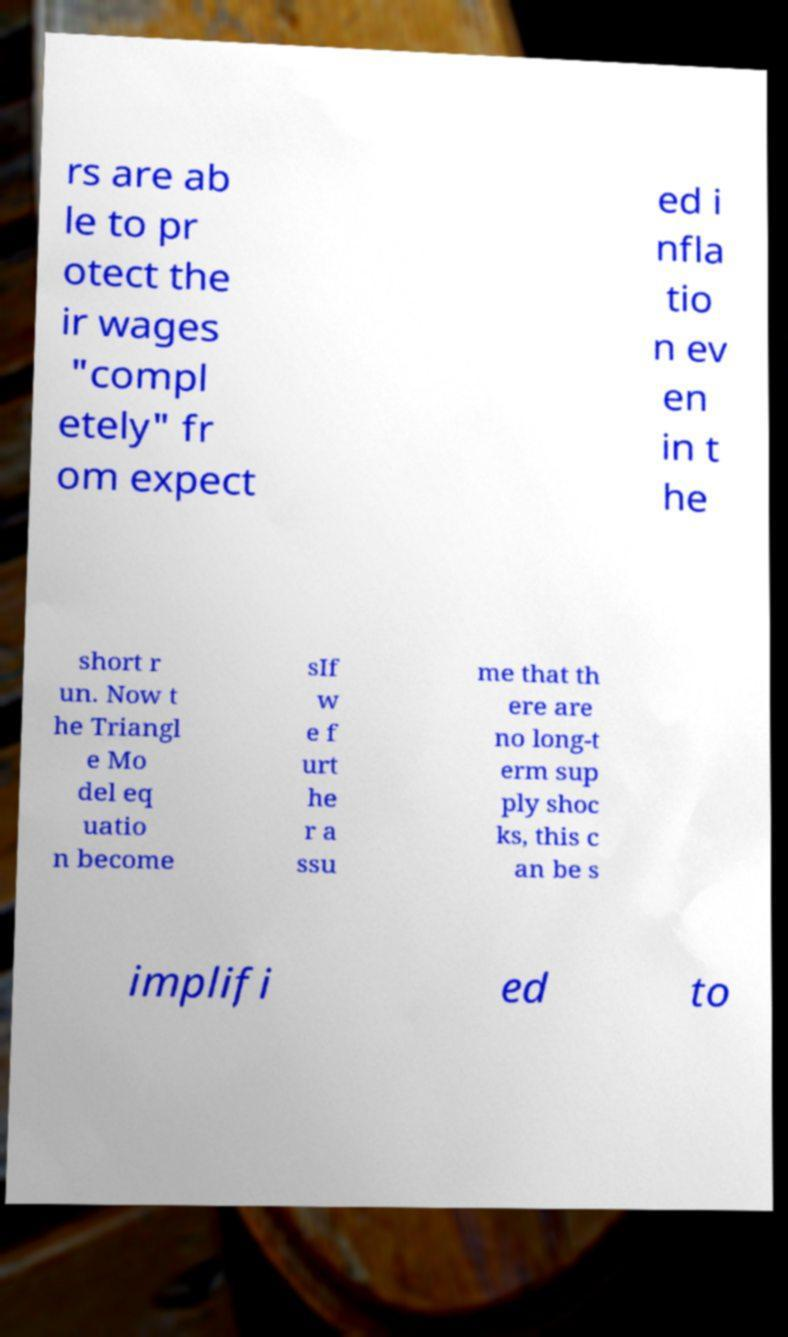Can you accurately transcribe the text from the provided image for me? rs are ab le to pr otect the ir wages "compl etely" fr om expect ed i nfla tio n ev en in t he short r un. Now t he Triangl e Mo del eq uatio n become sIf w e f urt he r a ssu me that th ere are no long-t erm sup ply shoc ks, this c an be s implifi ed to 